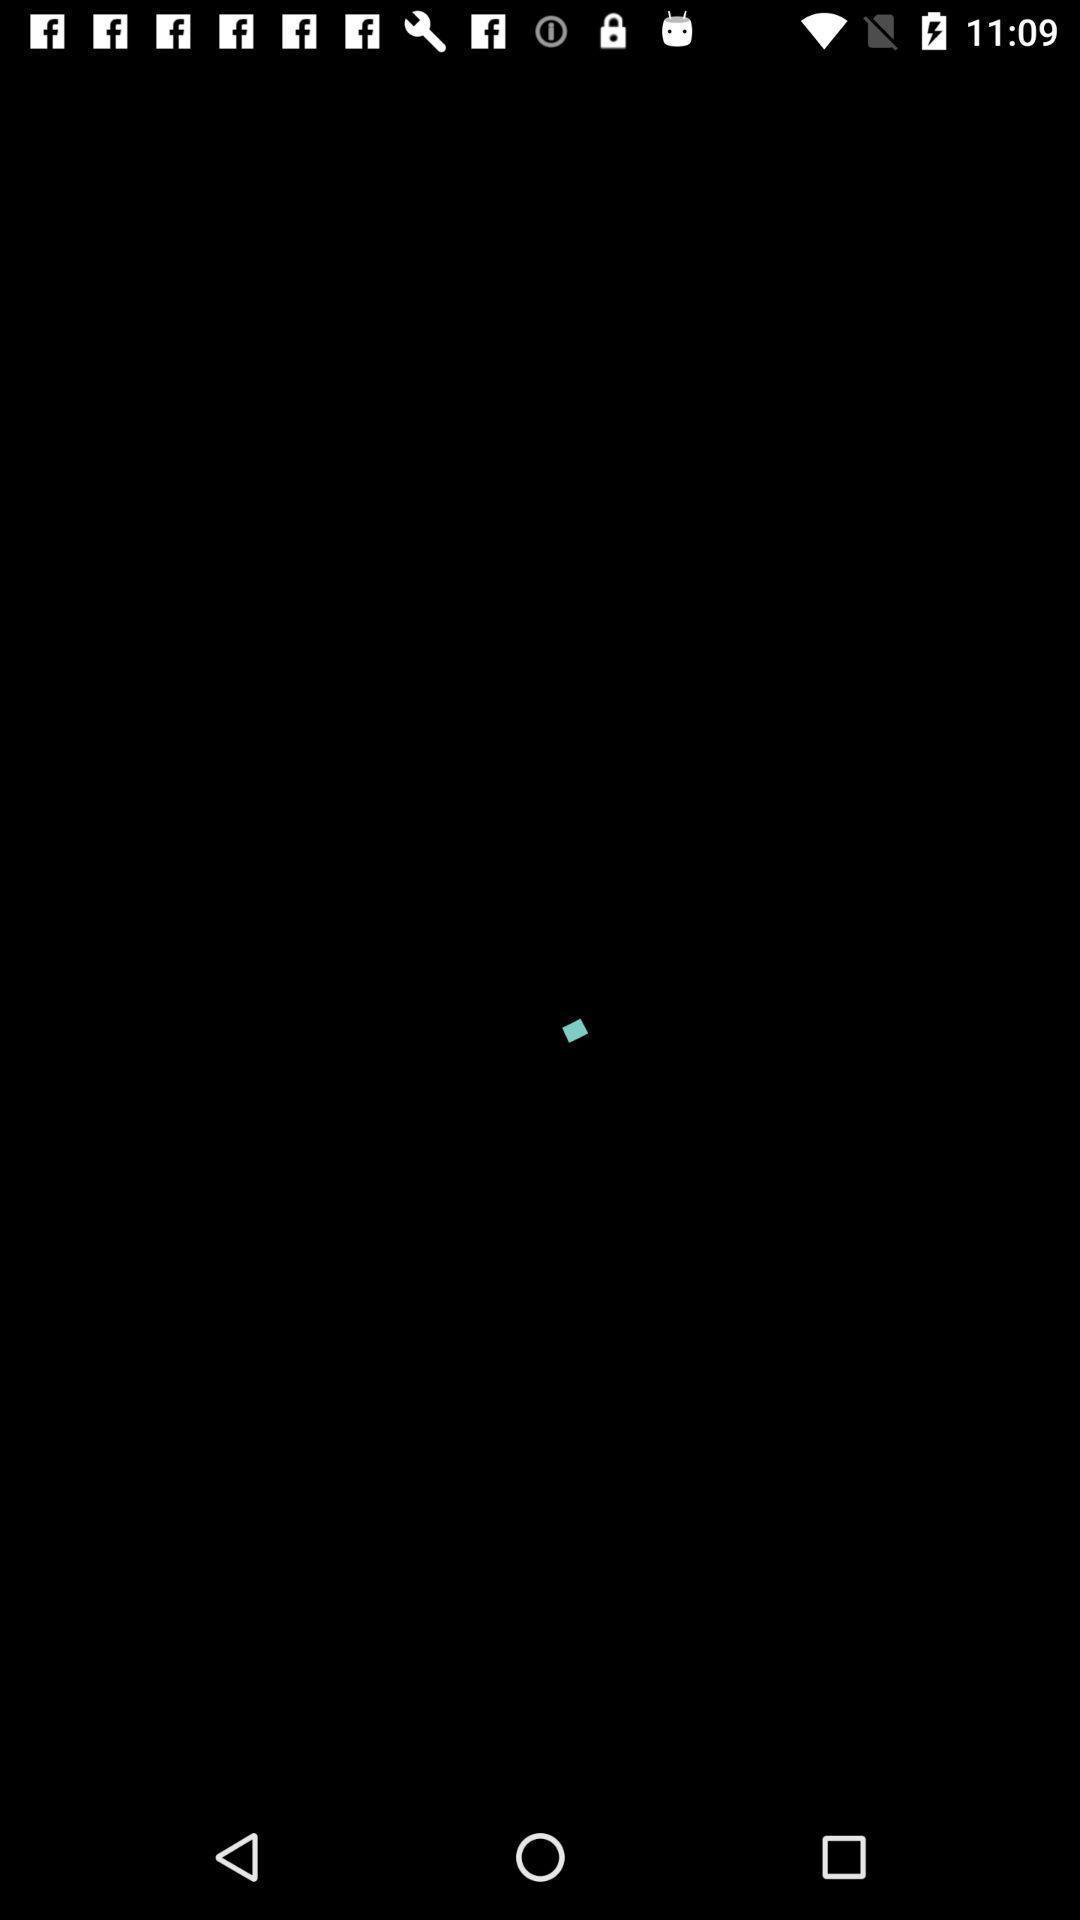What can you discern from this picture? Page displaying the loading page in news application. 